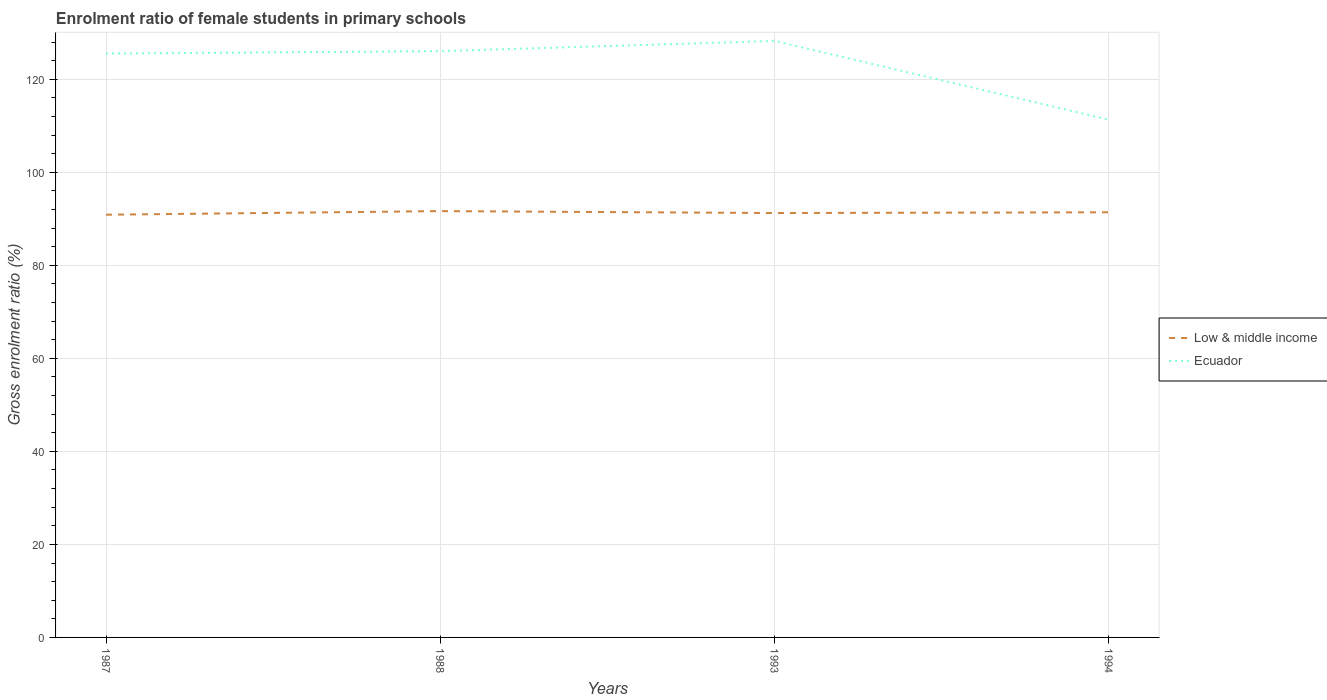Across all years, what is the maximum enrolment ratio of female students in primary schools in Low & middle income?
Make the answer very short. 90.89. What is the total enrolment ratio of female students in primary schools in Low & middle income in the graph?
Ensure brevity in your answer.  -0.36. What is the difference between the highest and the second highest enrolment ratio of female students in primary schools in Low & middle income?
Provide a succinct answer. 0.78. What is the difference between the highest and the lowest enrolment ratio of female students in primary schools in Ecuador?
Provide a succinct answer. 3. How many lines are there?
Make the answer very short. 2. What is the difference between two consecutive major ticks on the Y-axis?
Give a very brief answer. 20. Does the graph contain any zero values?
Offer a terse response. No. Does the graph contain grids?
Make the answer very short. Yes. Where does the legend appear in the graph?
Your response must be concise. Center right. How many legend labels are there?
Offer a terse response. 2. How are the legend labels stacked?
Give a very brief answer. Vertical. What is the title of the graph?
Your answer should be compact. Enrolment ratio of female students in primary schools. Does "Greece" appear as one of the legend labels in the graph?
Give a very brief answer. No. What is the label or title of the Y-axis?
Provide a short and direct response. Gross enrolment ratio (%). What is the Gross enrolment ratio (%) in Low & middle income in 1987?
Provide a succinct answer. 90.89. What is the Gross enrolment ratio (%) in Ecuador in 1987?
Provide a succinct answer. 125.53. What is the Gross enrolment ratio (%) in Low & middle income in 1988?
Your response must be concise. 91.67. What is the Gross enrolment ratio (%) in Ecuador in 1988?
Ensure brevity in your answer.  126.06. What is the Gross enrolment ratio (%) of Low & middle income in 1993?
Offer a terse response. 91.25. What is the Gross enrolment ratio (%) in Ecuador in 1993?
Give a very brief answer. 128.25. What is the Gross enrolment ratio (%) of Low & middle income in 1994?
Ensure brevity in your answer.  91.41. What is the Gross enrolment ratio (%) of Ecuador in 1994?
Ensure brevity in your answer.  111.32. Across all years, what is the maximum Gross enrolment ratio (%) of Low & middle income?
Provide a short and direct response. 91.67. Across all years, what is the maximum Gross enrolment ratio (%) of Ecuador?
Your answer should be compact. 128.25. Across all years, what is the minimum Gross enrolment ratio (%) in Low & middle income?
Ensure brevity in your answer.  90.89. Across all years, what is the minimum Gross enrolment ratio (%) of Ecuador?
Provide a short and direct response. 111.32. What is the total Gross enrolment ratio (%) of Low & middle income in the graph?
Your answer should be compact. 365.21. What is the total Gross enrolment ratio (%) in Ecuador in the graph?
Make the answer very short. 491.17. What is the difference between the Gross enrolment ratio (%) in Low & middle income in 1987 and that in 1988?
Offer a terse response. -0.78. What is the difference between the Gross enrolment ratio (%) in Ecuador in 1987 and that in 1988?
Give a very brief answer. -0.52. What is the difference between the Gross enrolment ratio (%) of Low & middle income in 1987 and that in 1993?
Give a very brief answer. -0.36. What is the difference between the Gross enrolment ratio (%) in Ecuador in 1987 and that in 1993?
Offer a terse response. -2.72. What is the difference between the Gross enrolment ratio (%) in Low & middle income in 1987 and that in 1994?
Keep it short and to the point. -0.52. What is the difference between the Gross enrolment ratio (%) of Ecuador in 1987 and that in 1994?
Your answer should be compact. 14.21. What is the difference between the Gross enrolment ratio (%) in Low & middle income in 1988 and that in 1993?
Ensure brevity in your answer.  0.41. What is the difference between the Gross enrolment ratio (%) of Ecuador in 1988 and that in 1993?
Make the answer very short. -2.19. What is the difference between the Gross enrolment ratio (%) of Low & middle income in 1988 and that in 1994?
Keep it short and to the point. 0.26. What is the difference between the Gross enrolment ratio (%) of Ecuador in 1988 and that in 1994?
Keep it short and to the point. 14.74. What is the difference between the Gross enrolment ratio (%) of Low & middle income in 1993 and that in 1994?
Your answer should be compact. -0.16. What is the difference between the Gross enrolment ratio (%) of Ecuador in 1993 and that in 1994?
Your response must be concise. 16.93. What is the difference between the Gross enrolment ratio (%) in Low & middle income in 1987 and the Gross enrolment ratio (%) in Ecuador in 1988?
Give a very brief answer. -35.17. What is the difference between the Gross enrolment ratio (%) of Low & middle income in 1987 and the Gross enrolment ratio (%) of Ecuador in 1993?
Make the answer very short. -37.36. What is the difference between the Gross enrolment ratio (%) of Low & middle income in 1987 and the Gross enrolment ratio (%) of Ecuador in 1994?
Your answer should be compact. -20.43. What is the difference between the Gross enrolment ratio (%) in Low & middle income in 1988 and the Gross enrolment ratio (%) in Ecuador in 1993?
Offer a very short reply. -36.59. What is the difference between the Gross enrolment ratio (%) of Low & middle income in 1988 and the Gross enrolment ratio (%) of Ecuador in 1994?
Keep it short and to the point. -19.66. What is the difference between the Gross enrolment ratio (%) in Low & middle income in 1993 and the Gross enrolment ratio (%) in Ecuador in 1994?
Ensure brevity in your answer.  -20.07. What is the average Gross enrolment ratio (%) in Low & middle income per year?
Ensure brevity in your answer.  91.3. What is the average Gross enrolment ratio (%) in Ecuador per year?
Provide a short and direct response. 122.79. In the year 1987, what is the difference between the Gross enrolment ratio (%) in Low & middle income and Gross enrolment ratio (%) in Ecuador?
Your answer should be compact. -34.65. In the year 1988, what is the difference between the Gross enrolment ratio (%) of Low & middle income and Gross enrolment ratio (%) of Ecuador?
Ensure brevity in your answer.  -34.39. In the year 1993, what is the difference between the Gross enrolment ratio (%) of Low & middle income and Gross enrolment ratio (%) of Ecuador?
Your answer should be very brief. -37. In the year 1994, what is the difference between the Gross enrolment ratio (%) in Low & middle income and Gross enrolment ratio (%) in Ecuador?
Ensure brevity in your answer.  -19.91. What is the ratio of the Gross enrolment ratio (%) in Low & middle income in 1987 to that in 1993?
Your answer should be very brief. 1. What is the ratio of the Gross enrolment ratio (%) of Ecuador in 1987 to that in 1993?
Offer a very short reply. 0.98. What is the ratio of the Gross enrolment ratio (%) of Ecuador in 1987 to that in 1994?
Provide a short and direct response. 1.13. What is the ratio of the Gross enrolment ratio (%) of Ecuador in 1988 to that in 1993?
Keep it short and to the point. 0.98. What is the ratio of the Gross enrolment ratio (%) in Low & middle income in 1988 to that in 1994?
Your response must be concise. 1. What is the ratio of the Gross enrolment ratio (%) in Ecuador in 1988 to that in 1994?
Give a very brief answer. 1.13. What is the ratio of the Gross enrolment ratio (%) of Ecuador in 1993 to that in 1994?
Ensure brevity in your answer.  1.15. What is the difference between the highest and the second highest Gross enrolment ratio (%) in Low & middle income?
Give a very brief answer. 0.26. What is the difference between the highest and the second highest Gross enrolment ratio (%) of Ecuador?
Provide a succinct answer. 2.19. What is the difference between the highest and the lowest Gross enrolment ratio (%) in Low & middle income?
Ensure brevity in your answer.  0.78. What is the difference between the highest and the lowest Gross enrolment ratio (%) of Ecuador?
Make the answer very short. 16.93. 